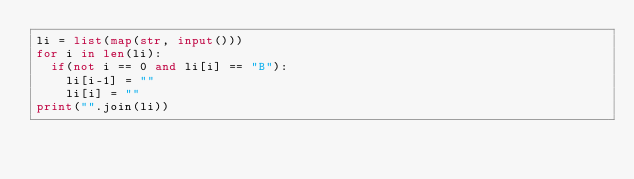<code> <loc_0><loc_0><loc_500><loc_500><_Python_>li = list(map(str, input()))
for i in len(li):
  if(not i == 0 and li[i] == "B"): 
    li[i-1] = ""
    li[i] = ""
print("".join(li))</code> 